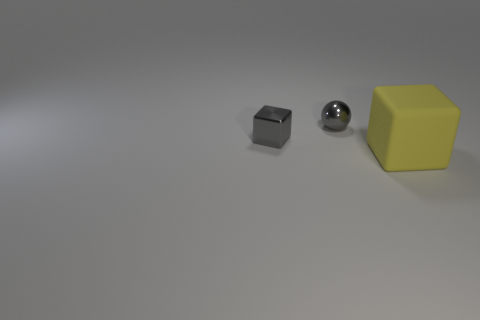What might be the purpose of these objects if they were part of a larger set or collection? These objects could be part of a set designed for educational purposes, such as a geometry demonstration kit, where the consistent size helps to illustrate differences in shape without the confounding factor of differing scales. Could this image be used in any other contexts apart from education? Absolutely, such an image could be utilized in art for compositional studies, in advertisements for minimalist themes, or even in a psychological test to evaluate perception and spatial reasoning. 